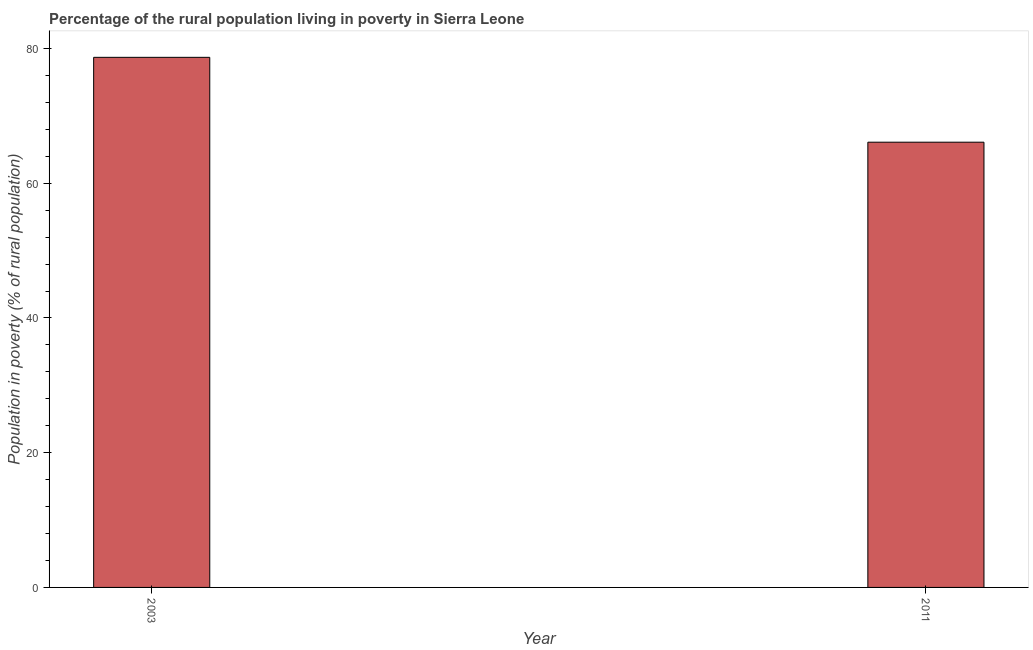Does the graph contain any zero values?
Your response must be concise. No. Does the graph contain grids?
Ensure brevity in your answer.  No. What is the title of the graph?
Your response must be concise. Percentage of the rural population living in poverty in Sierra Leone. What is the label or title of the X-axis?
Ensure brevity in your answer.  Year. What is the label or title of the Y-axis?
Your response must be concise. Population in poverty (% of rural population). What is the percentage of rural population living below poverty line in 2011?
Offer a very short reply. 66.1. Across all years, what is the maximum percentage of rural population living below poverty line?
Provide a short and direct response. 78.7. Across all years, what is the minimum percentage of rural population living below poverty line?
Make the answer very short. 66.1. In which year was the percentage of rural population living below poverty line maximum?
Offer a terse response. 2003. In which year was the percentage of rural population living below poverty line minimum?
Give a very brief answer. 2011. What is the sum of the percentage of rural population living below poverty line?
Give a very brief answer. 144.8. What is the average percentage of rural population living below poverty line per year?
Give a very brief answer. 72.4. What is the median percentage of rural population living below poverty line?
Provide a short and direct response. 72.4. In how many years, is the percentage of rural population living below poverty line greater than 36 %?
Your response must be concise. 2. Do a majority of the years between 2003 and 2011 (inclusive) have percentage of rural population living below poverty line greater than 64 %?
Provide a short and direct response. Yes. What is the ratio of the percentage of rural population living below poverty line in 2003 to that in 2011?
Make the answer very short. 1.19. Are the values on the major ticks of Y-axis written in scientific E-notation?
Your answer should be compact. No. What is the Population in poverty (% of rural population) in 2003?
Your response must be concise. 78.7. What is the Population in poverty (% of rural population) in 2011?
Offer a very short reply. 66.1. What is the difference between the Population in poverty (% of rural population) in 2003 and 2011?
Keep it short and to the point. 12.6. What is the ratio of the Population in poverty (% of rural population) in 2003 to that in 2011?
Keep it short and to the point. 1.19. 